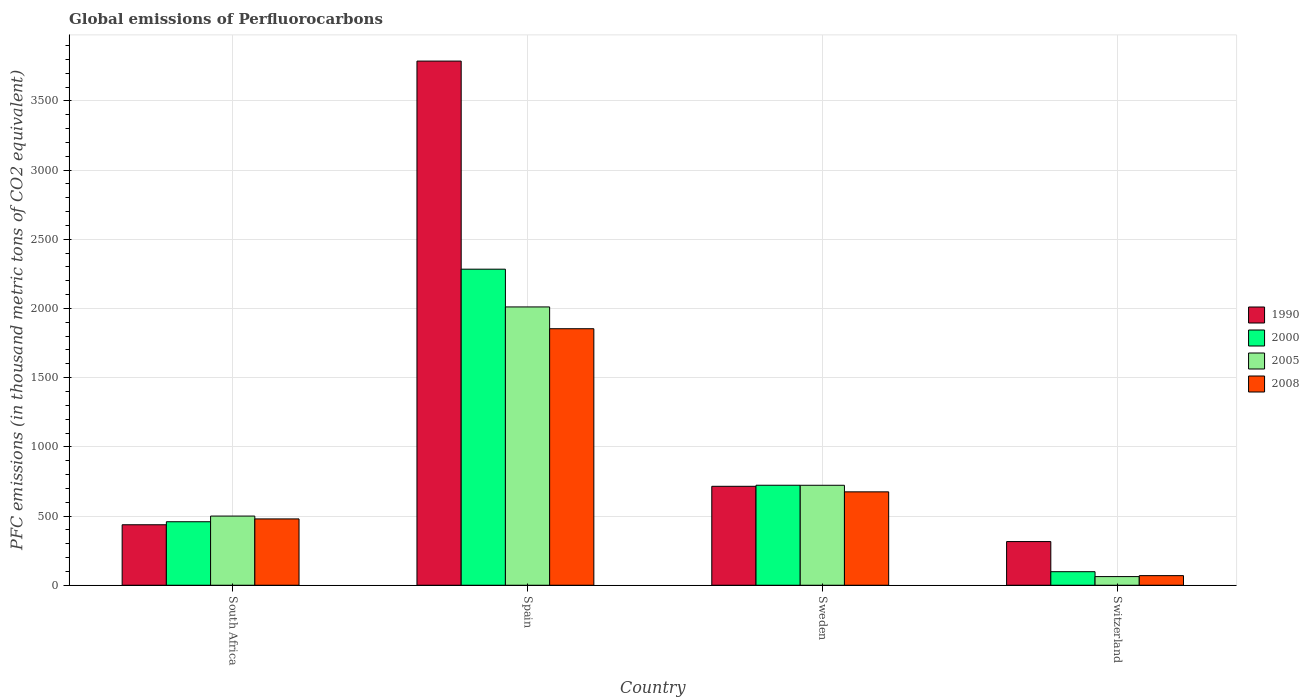How many different coloured bars are there?
Your answer should be compact. 4. How many bars are there on the 1st tick from the left?
Your answer should be very brief. 4. How many bars are there on the 4th tick from the right?
Your answer should be compact. 4. What is the label of the 2nd group of bars from the left?
Offer a very short reply. Spain. In how many cases, is the number of bars for a given country not equal to the number of legend labels?
Keep it short and to the point. 0. What is the global emissions of Perfluorocarbons in 1990 in Sweden?
Offer a terse response. 714.9. Across all countries, what is the maximum global emissions of Perfluorocarbons in 2008?
Offer a very short reply. 1853.5. Across all countries, what is the minimum global emissions of Perfluorocarbons in 1990?
Provide a succinct answer. 315.5. In which country was the global emissions of Perfluorocarbons in 1990 minimum?
Provide a short and direct response. Switzerland. What is the total global emissions of Perfluorocarbons in 2008 in the graph?
Ensure brevity in your answer.  3076.9. What is the difference between the global emissions of Perfluorocarbons in 2008 in Sweden and that in Switzerland?
Your response must be concise. 605.4. What is the difference between the global emissions of Perfluorocarbons in 2005 in Switzerland and the global emissions of Perfluorocarbons in 2008 in Spain?
Your answer should be compact. -1791. What is the average global emissions of Perfluorocarbons in 1990 per country?
Keep it short and to the point. 1313.7. What is the difference between the global emissions of Perfluorocarbons of/in 2005 and global emissions of Perfluorocarbons of/in 2000 in Spain?
Your answer should be very brief. -272.8. In how many countries, is the global emissions of Perfluorocarbons in 2000 greater than 1500 thousand metric tons?
Provide a short and direct response. 1. What is the ratio of the global emissions of Perfluorocarbons in 1990 in South Africa to that in Sweden?
Give a very brief answer. 0.61. Is the global emissions of Perfluorocarbons in 2005 in Sweden less than that in Switzerland?
Offer a terse response. No. Is the difference between the global emissions of Perfluorocarbons in 2005 in Spain and Switzerland greater than the difference between the global emissions of Perfluorocarbons in 2000 in Spain and Switzerland?
Ensure brevity in your answer.  No. What is the difference between the highest and the second highest global emissions of Perfluorocarbons in 2000?
Provide a short and direct response. -263.7. What is the difference between the highest and the lowest global emissions of Perfluorocarbons in 2000?
Give a very brief answer. 2185.9. In how many countries, is the global emissions of Perfluorocarbons in 2000 greater than the average global emissions of Perfluorocarbons in 2000 taken over all countries?
Make the answer very short. 1. Is the sum of the global emissions of Perfluorocarbons in 2008 in South Africa and Spain greater than the maximum global emissions of Perfluorocarbons in 1990 across all countries?
Make the answer very short. No. What does the 1st bar from the right in Spain represents?
Provide a short and direct response. 2008. How many bars are there?
Make the answer very short. 16. Are the values on the major ticks of Y-axis written in scientific E-notation?
Provide a succinct answer. No. Does the graph contain any zero values?
Make the answer very short. No. What is the title of the graph?
Offer a terse response. Global emissions of Perfluorocarbons. Does "1978" appear as one of the legend labels in the graph?
Your response must be concise. No. What is the label or title of the Y-axis?
Offer a very short reply. PFC emissions (in thousand metric tons of CO2 equivalent). What is the PFC emissions (in thousand metric tons of CO2 equivalent) of 1990 in South Africa?
Provide a short and direct response. 437. What is the PFC emissions (in thousand metric tons of CO2 equivalent) of 2000 in South Africa?
Your response must be concise. 458.8. What is the PFC emissions (in thousand metric tons of CO2 equivalent) of 2005 in South Africa?
Offer a very short reply. 499.8. What is the PFC emissions (in thousand metric tons of CO2 equivalent) in 2008 in South Africa?
Your answer should be compact. 479.2. What is the PFC emissions (in thousand metric tons of CO2 equivalent) of 1990 in Spain?
Your response must be concise. 3787.4. What is the PFC emissions (in thousand metric tons of CO2 equivalent) of 2000 in Spain?
Provide a short and direct response. 2283.8. What is the PFC emissions (in thousand metric tons of CO2 equivalent) of 2005 in Spain?
Offer a terse response. 2011. What is the PFC emissions (in thousand metric tons of CO2 equivalent) in 2008 in Spain?
Offer a very short reply. 1853.5. What is the PFC emissions (in thousand metric tons of CO2 equivalent) of 1990 in Sweden?
Provide a short and direct response. 714.9. What is the PFC emissions (in thousand metric tons of CO2 equivalent) of 2000 in Sweden?
Give a very brief answer. 722.5. What is the PFC emissions (in thousand metric tons of CO2 equivalent) in 2005 in Sweden?
Provide a succinct answer. 722.3. What is the PFC emissions (in thousand metric tons of CO2 equivalent) of 2008 in Sweden?
Ensure brevity in your answer.  674.8. What is the PFC emissions (in thousand metric tons of CO2 equivalent) in 1990 in Switzerland?
Your response must be concise. 315.5. What is the PFC emissions (in thousand metric tons of CO2 equivalent) in 2000 in Switzerland?
Your answer should be compact. 97.9. What is the PFC emissions (in thousand metric tons of CO2 equivalent) of 2005 in Switzerland?
Offer a terse response. 62.5. What is the PFC emissions (in thousand metric tons of CO2 equivalent) in 2008 in Switzerland?
Your answer should be compact. 69.4. Across all countries, what is the maximum PFC emissions (in thousand metric tons of CO2 equivalent) of 1990?
Provide a short and direct response. 3787.4. Across all countries, what is the maximum PFC emissions (in thousand metric tons of CO2 equivalent) of 2000?
Keep it short and to the point. 2283.8. Across all countries, what is the maximum PFC emissions (in thousand metric tons of CO2 equivalent) of 2005?
Give a very brief answer. 2011. Across all countries, what is the maximum PFC emissions (in thousand metric tons of CO2 equivalent) in 2008?
Provide a succinct answer. 1853.5. Across all countries, what is the minimum PFC emissions (in thousand metric tons of CO2 equivalent) of 1990?
Ensure brevity in your answer.  315.5. Across all countries, what is the minimum PFC emissions (in thousand metric tons of CO2 equivalent) of 2000?
Your response must be concise. 97.9. Across all countries, what is the minimum PFC emissions (in thousand metric tons of CO2 equivalent) in 2005?
Make the answer very short. 62.5. Across all countries, what is the minimum PFC emissions (in thousand metric tons of CO2 equivalent) of 2008?
Keep it short and to the point. 69.4. What is the total PFC emissions (in thousand metric tons of CO2 equivalent) in 1990 in the graph?
Provide a short and direct response. 5254.8. What is the total PFC emissions (in thousand metric tons of CO2 equivalent) of 2000 in the graph?
Your answer should be compact. 3563. What is the total PFC emissions (in thousand metric tons of CO2 equivalent) of 2005 in the graph?
Give a very brief answer. 3295.6. What is the total PFC emissions (in thousand metric tons of CO2 equivalent) of 2008 in the graph?
Your answer should be compact. 3076.9. What is the difference between the PFC emissions (in thousand metric tons of CO2 equivalent) of 1990 in South Africa and that in Spain?
Keep it short and to the point. -3350.4. What is the difference between the PFC emissions (in thousand metric tons of CO2 equivalent) in 2000 in South Africa and that in Spain?
Ensure brevity in your answer.  -1825. What is the difference between the PFC emissions (in thousand metric tons of CO2 equivalent) in 2005 in South Africa and that in Spain?
Keep it short and to the point. -1511.2. What is the difference between the PFC emissions (in thousand metric tons of CO2 equivalent) in 2008 in South Africa and that in Spain?
Offer a very short reply. -1374.3. What is the difference between the PFC emissions (in thousand metric tons of CO2 equivalent) in 1990 in South Africa and that in Sweden?
Ensure brevity in your answer.  -277.9. What is the difference between the PFC emissions (in thousand metric tons of CO2 equivalent) of 2000 in South Africa and that in Sweden?
Keep it short and to the point. -263.7. What is the difference between the PFC emissions (in thousand metric tons of CO2 equivalent) of 2005 in South Africa and that in Sweden?
Keep it short and to the point. -222.5. What is the difference between the PFC emissions (in thousand metric tons of CO2 equivalent) in 2008 in South Africa and that in Sweden?
Provide a succinct answer. -195.6. What is the difference between the PFC emissions (in thousand metric tons of CO2 equivalent) in 1990 in South Africa and that in Switzerland?
Offer a very short reply. 121.5. What is the difference between the PFC emissions (in thousand metric tons of CO2 equivalent) in 2000 in South Africa and that in Switzerland?
Ensure brevity in your answer.  360.9. What is the difference between the PFC emissions (in thousand metric tons of CO2 equivalent) of 2005 in South Africa and that in Switzerland?
Keep it short and to the point. 437.3. What is the difference between the PFC emissions (in thousand metric tons of CO2 equivalent) in 2008 in South Africa and that in Switzerland?
Offer a very short reply. 409.8. What is the difference between the PFC emissions (in thousand metric tons of CO2 equivalent) in 1990 in Spain and that in Sweden?
Make the answer very short. 3072.5. What is the difference between the PFC emissions (in thousand metric tons of CO2 equivalent) in 2000 in Spain and that in Sweden?
Offer a very short reply. 1561.3. What is the difference between the PFC emissions (in thousand metric tons of CO2 equivalent) of 2005 in Spain and that in Sweden?
Offer a terse response. 1288.7. What is the difference between the PFC emissions (in thousand metric tons of CO2 equivalent) of 2008 in Spain and that in Sweden?
Your answer should be compact. 1178.7. What is the difference between the PFC emissions (in thousand metric tons of CO2 equivalent) of 1990 in Spain and that in Switzerland?
Offer a very short reply. 3471.9. What is the difference between the PFC emissions (in thousand metric tons of CO2 equivalent) of 2000 in Spain and that in Switzerland?
Give a very brief answer. 2185.9. What is the difference between the PFC emissions (in thousand metric tons of CO2 equivalent) in 2005 in Spain and that in Switzerland?
Give a very brief answer. 1948.5. What is the difference between the PFC emissions (in thousand metric tons of CO2 equivalent) in 2008 in Spain and that in Switzerland?
Provide a short and direct response. 1784.1. What is the difference between the PFC emissions (in thousand metric tons of CO2 equivalent) in 1990 in Sweden and that in Switzerland?
Keep it short and to the point. 399.4. What is the difference between the PFC emissions (in thousand metric tons of CO2 equivalent) of 2000 in Sweden and that in Switzerland?
Make the answer very short. 624.6. What is the difference between the PFC emissions (in thousand metric tons of CO2 equivalent) in 2005 in Sweden and that in Switzerland?
Provide a succinct answer. 659.8. What is the difference between the PFC emissions (in thousand metric tons of CO2 equivalent) in 2008 in Sweden and that in Switzerland?
Provide a succinct answer. 605.4. What is the difference between the PFC emissions (in thousand metric tons of CO2 equivalent) in 1990 in South Africa and the PFC emissions (in thousand metric tons of CO2 equivalent) in 2000 in Spain?
Your answer should be very brief. -1846.8. What is the difference between the PFC emissions (in thousand metric tons of CO2 equivalent) in 1990 in South Africa and the PFC emissions (in thousand metric tons of CO2 equivalent) in 2005 in Spain?
Make the answer very short. -1574. What is the difference between the PFC emissions (in thousand metric tons of CO2 equivalent) in 1990 in South Africa and the PFC emissions (in thousand metric tons of CO2 equivalent) in 2008 in Spain?
Give a very brief answer. -1416.5. What is the difference between the PFC emissions (in thousand metric tons of CO2 equivalent) of 2000 in South Africa and the PFC emissions (in thousand metric tons of CO2 equivalent) of 2005 in Spain?
Provide a short and direct response. -1552.2. What is the difference between the PFC emissions (in thousand metric tons of CO2 equivalent) in 2000 in South Africa and the PFC emissions (in thousand metric tons of CO2 equivalent) in 2008 in Spain?
Your answer should be compact. -1394.7. What is the difference between the PFC emissions (in thousand metric tons of CO2 equivalent) of 2005 in South Africa and the PFC emissions (in thousand metric tons of CO2 equivalent) of 2008 in Spain?
Your answer should be very brief. -1353.7. What is the difference between the PFC emissions (in thousand metric tons of CO2 equivalent) of 1990 in South Africa and the PFC emissions (in thousand metric tons of CO2 equivalent) of 2000 in Sweden?
Offer a very short reply. -285.5. What is the difference between the PFC emissions (in thousand metric tons of CO2 equivalent) in 1990 in South Africa and the PFC emissions (in thousand metric tons of CO2 equivalent) in 2005 in Sweden?
Ensure brevity in your answer.  -285.3. What is the difference between the PFC emissions (in thousand metric tons of CO2 equivalent) in 1990 in South Africa and the PFC emissions (in thousand metric tons of CO2 equivalent) in 2008 in Sweden?
Keep it short and to the point. -237.8. What is the difference between the PFC emissions (in thousand metric tons of CO2 equivalent) in 2000 in South Africa and the PFC emissions (in thousand metric tons of CO2 equivalent) in 2005 in Sweden?
Offer a terse response. -263.5. What is the difference between the PFC emissions (in thousand metric tons of CO2 equivalent) in 2000 in South Africa and the PFC emissions (in thousand metric tons of CO2 equivalent) in 2008 in Sweden?
Make the answer very short. -216. What is the difference between the PFC emissions (in thousand metric tons of CO2 equivalent) of 2005 in South Africa and the PFC emissions (in thousand metric tons of CO2 equivalent) of 2008 in Sweden?
Your answer should be very brief. -175. What is the difference between the PFC emissions (in thousand metric tons of CO2 equivalent) in 1990 in South Africa and the PFC emissions (in thousand metric tons of CO2 equivalent) in 2000 in Switzerland?
Your answer should be very brief. 339.1. What is the difference between the PFC emissions (in thousand metric tons of CO2 equivalent) in 1990 in South Africa and the PFC emissions (in thousand metric tons of CO2 equivalent) in 2005 in Switzerland?
Your answer should be very brief. 374.5. What is the difference between the PFC emissions (in thousand metric tons of CO2 equivalent) of 1990 in South Africa and the PFC emissions (in thousand metric tons of CO2 equivalent) of 2008 in Switzerland?
Provide a short and direct response. 367.6. What is the difference between the PFC emissions (in thousand metric tons of CO2 equivalent) in 2000 in South Africa and the PFC emissions (in thousand metric tons of CO2 equivalent) in 2005 in Switzerland?
Make the answer very short. 396.3. What is the difference between the PFC emissions (in thousand metric tons of CO2 equivalent) in 2000 in South Africa and the PFC emissions (in thousand metric tons of CO2 equivalent) in 2008 in Switzerland?
Your answer should be very brief. 389.4. What is the difference between the PFC emissions (in thousand metric tons of CO2 equivalent) of 2005 in South Africa and the PFC emissions (in thousand metric tons of CO2 equivalent) of 2008 in Switzerland?
Your response must be concise. 430.4. What is the difference between the PFC emissions (in thousand metric tons of CO2 equivalent) in 1990 in Spain and the PFC emissions (in thousand metric tons of CO2 equivalent) in 2000 in Sweden?
Your answer should be compact. 3064.9. What is the difference between the PFC emissions (in thousand metric tons of CO2 equivalent) of 1990 in Spain and the PFC emissions (in thousand metric tons of CO2 equivalent) of 2005 in Sweden?
Offer a very short reply. 3065.1. What is the difference between the PFC emissions (in thousand metric tons of CO2 equivalent) of 1990 in Spain and the PFC emissions (in thousand metric tons of CO2 equivalent) of 2008 in Sweden?
Provide a short and direct response. 3112.6. What is the difference between the PFC emissions (in thousand metric tons of CO2 equivalent) in 2000 in Spain and the PFC emissions (in thousand metric tons of CO2 equivalent) in 2005 in Sweden?
Ensure brevity in your answer.  1561.5. What is the difference between the PFC emissions (in thousand metric tons of CO2 equivalent) in 2000 in Spain and the PFC emissions (in thousand metric tons of CO2 equivalent) in 2008 in Sweden?
Your answer should be compact. 1609. What is the difference between the PFC emissions (in thousand metric tons of CO2 equivalent) of 2005 in Spain and the PFC emissions (in thousand metric tons of CO2 equivalent) of 2008 in Sweden?
Provide a short and direct response. 1336.2. What is the difference between the PFC emissions (in thousand metric tons of CO2 equivalent) in 1990 in Spain and the PFC emissions (in thousand metric tons of CO2 equivalent) in 2000 in Switzerland?
Provide a succinct answer. 3689.5. What is the difference between the PFC emissions (in thousand metric tons of CO2 equivalent) of 1990 in Spain and the PFC emissions (in thousand metric tons of CO2 equivalent) of 2005 in Switzerland?
Offer a very short reply. 3724.9. What is the difference between the PFC emissions (in thousand metric tons of CO2 equivalent) of 1990 in Spain and the PFC emissions (in thousand metric tons of CO2 equivalent) of 2008 in Switzerland?
Your response must be concise. 3718. What is the difference between the PFC emissions (in thousand metric tons of CO2 equivalent) of 2000 in Spain and the PFC emissions (in thousand metric tons of CO2 equivalent) of 2005 in Switzerland?
Keep it short and to the point. 2221.3. What is the difference between the PFC emissions (in thousand metric tons of CO2 equivalent) in 2000 in Spain and the PFC emissions (in thousand metric tons of CO2 equivalent) in 2008 in Switzerland?
Your answer should be compact. 2214.4. What is the difference between the PFC emissions (in thousand metric tons of CO2 equivalent) in 2005 in Spain and the PFC emissions (in thousand metric tons of CO2 equivalent) in 2008 in Switzerland?
Your response must be concise. 1941.6. What is the difference between the PFC emissions (in thousand metric tons of CO2 equivalent) of 1990 in Sweden and the PFC emissions (in thousand metric tons of CO2 equivalent) of 2000 in Switzerland?
Give a very brief answer. 617. What is the difference between the PFC emissions (in thousand metric tons of CO2 equivalent) in 1990 in Sweden and the PFC emissions (in thousand metric tons of CO2 equivalent) in 2005 in Switzerland?
Give a very brief answer. 652.4. What is the difference between the PFC emissions (in thousand metric tons of CO2 equivalent) in 1990 in Sweden and the PFC emissions (in thousand metric tons of CO2 equivalent) in 2008 in Switzerland?
Offer a terse response. 645.5. What is the difference between the PFC emissions (in thousand metric tons of CO2 equivalent) of 2000 in Sweden and the PFC emissions (in thousand metric tons of CO2 equivalent) of 2005 in Switzerland?
Your response must be concise. 660. What is the difference between the PFC emissions (in thousand metric tons of CO2 equivalent) of 2000 in Sweden and the PFC emissions (in thousand metric tons of CO2 equivalent) of 2008 in Switzerland?
Make the answer very short. 653.1. What is the difference between the PFC emissions (in thousand metric tons of CO2 equivalent) of 2005 in Sweden and the PFC emissions (in thousand metric tons of CO2 equivalent) of 2008 in Switzerland?
Ensure brevity in your answer.  652.9. What is the average PFC emissions (in thousand metric tons of CO2 equivalent) in 1990 per country?
Offer a terse response. 1313.7. What is the average PFC emissions (in thousand metric tons of CO2 equivalent) in 2000 per country?
Provide a short and direct response. 890.75. What is the average PFC emissions (in thousand metric tons of CO2 equivalent) in 2005 per country?
Your answer should be very brief. 823.9. What is the average PFC emissions (in thousand metric tons of CO2 equivalent) in 2008 per country?
Ensure brevity in your answer.  769.23. What is the difference between the PFC emissions (in thousand metric tons of CO2 equivalent) in 1990 and PFC emissions (in thousand metric tons of CO2 equivalent) in 2000 in South Africa?
Ensure brevity in your answer.  -21.8. What is the difference between the PFC emissions (in thousand metric tons of CO2 equivalent) in 1990 and PFC emissions (in thousand metric tons of CO2 equivalent) in 2005 in South Africa?
Keep it short and to the point. -62.8. What is the difference between the PFC emissions (in thousand metric tons of CO2 equivalent) in 1990 and PFC emissions (in thousand metric tons of CO2 equivalent) in 2008 in South Africa?
Your answer should be compact. -42.2. What is the difference between the PFC emissions (in thousand metric tons of CO2 equivalent) in 2000 and PFC emissions (in thousand metric tons of CO2 equivalent) in 2005 in South Africa?
Your response must be concise. -41. What is the difference between the PFC emissions (in thousand metric tons of CO2 equivalent) of 2000 and PFC emissions (in thousand metric tons of CO2 equivalent) of 2008 in South Africa?
Provide a short and direct response. -20.4. What is the difference between the PFC emissions (in thousand metric tons of CO2 equivalent) of 2005 and PFC emissions (in thousand metric tons of CO2 equivalent) of 2008 in South Africa?
Give a very brief answer. 20.6. What is the difference between the PFC emissions (in thousand metric tons of CO2 equivalent) of 1990 and PFC emissions (in thousand metric tons of CO2 equivalent) of 2000 in Spain?
Your response must be concise. 1503.6. What is the difference between the PFC emissions (in thousand metric tons of CO2 equivalent) in 1990 and PFC emissions (in thousand metric tons of CO2 equivalent) in 2005 in Spain?
Keep it short and to the point. 1776.4. What is the difference between the PFC emissions (in thousand metric tons of CO2 equivalent) in 1990 and PFC emissions (in thousand metric tons of CO2 equivalent) in 2008 in Spain?
Make the answer very short. 1933.9. What is the difference between the PFC emissions (in thousand metric tons of CO2 equivalent) in 2000 and PFC emissions (in thousand metric tons of CO2 equivalent) in 2005 in Spain?
Your answer should be very brief. 272.8. What is the difference between the PFC emissions (in thousand metric tons of CO2 equivalent) in 2000 and PFC emissions (in thousand metric tons of CO2 equivalent) in 2008 in Spain?
Offer a very short reply. 430.3. What is the difference between the PFC emissions (in thousand metric tons of CO2 equivalent) of 2005 and PFC emissions (in thousand metric tons of CO2 equivalent) of 2008 in Spain?
Your answer should be compact. 157.5. What is the difference between the PFC emissions (in thousand metric tons of CO2 equivalent) of 1990 and PFC emissions (in thousand metric tons of CO2 equivalent) of 2005 in Sweden?
Keep it short and to the point. -7.4. What is the difference between the PFC emissions (in thousand metric tons of CO2 equivalent) of 1990 and PFC emissions (in thousand metric tons of CO2 equivalent) of 2008 in Sweden?
Provide a succinct answer. 40.1. What is the difference between the PFC emissions (in thousand metric tons of CO2 equivalent) of 2000 and PFC emissions (in thousand metric tons of CO2 equivalent) of 2005 in Sweden?
Offer a terse response. 0.2. What is the difference between the PFC emissions (in thousand metric tons of CO2 equivalent) in 2000 and PFC emissions (in thousand metric tons of CO2 equivalent) in 2008 in Sweden?
Provide a succinct answer. 47.7. What is the difference between the PFC emissions (in thousand metric tons of CO2 equivalent) of 2005 and PFC emissions (in thousand metric tons of CO2 equivalent) of 2008 in Sweden?
Keep it short and to the point. 47.5. What is the difference between the PFC emissions (in thousand metric tons of CO2 equivalent) in 1990 and PFC emissions (in thousand metric tons of CO2 equivalent) in 2000 in Switzerland?
Your answer should be compact. 217.6. What is the difference between the PFC emissions (in thousand metric tons of CO2 equivalent) of 1990 and PFC emissions (in thousand metric tons of CO2 equivalent) of 2005 in Switzerland?
Provide a short and direct response. 253. What is the difference between the PFC emissions (in thousand metric tons of CO2 equivalent) in 1990 and PFC emissions (in thousand metric tons of CO2 equivalent) in 2008 in Switzerland?
Keep it short and to the point. 246.1. What is the difference between the PFC emissions (in thousand metric tons of CO2 equivalent) of 2000 and PFC emissions (in thousand metric tons of CO2 equivalent) of 2005 in Switzerland?
Give a very brief answer. 35.4. What is the difference between the PFC emissions (in thousand metric tons of CO2 equivalent) of 2005 and PFC emissions (in thousand metric tons of CO2 equivalent) of 2008 in Switzerland?
Ensure brevity in your answer.  -6.9. What is the ratio of the PFC emissions (in thousand metric tons of CO2 equivalent) of 1990 in South Africa to that in Spain?
Give a very brief answer. 0.12. What is the ratio of the PFC emissions (in thousand metric tons of CO2 equivalent) of 2000 in South Africa to that in Spain?
Offer a very short reply. 0.2. What is the ratio of the PFC emissions (in thousand metric tons of CO2 equivalent) of 2005 in South Africa to that in Spain?
Your answer should be very brief. 0.25. What is the ratio of the PFC emissions (in thousand metric tons of CO2 equivalent) in 2008 in South Africa to that in Spain?
Your answer should be very brief. 0.26. What is the ratio of the PFC emissions (in thousand metric tons of CO2 equivalent) in 1990 in South Africa to that in Sweden?
Your response must be concise. 0.61. What is the ratio of the PFC emissions (in thousand metric tons of CO2 equivalent) in 2000 in South Africa to that in Sweden?
Offer a terse response. 0.64. What is the ratio of the PFC emissions (in thousand metric tons of CO2 equivalent) of 2005 in South Africa to that in Sweden?
Your answer should be very brief. 0.69. What is the ratio of the PFC emissions (in thousand metric tons of CO2 equivalent) in 2008 in South Africa to that in Sweden?
Offer a terse response. 0.71. What is the ratio of the PFC emissions (in thousand metric tons of CO2 equivalent) in 1990 in South Africa to that in Switzerland?
Provide a succinct answer. 1.39. What is the ratio of the PFC emissions (in thousand metric tons of CO2 equivalent) of 2000 in South Africa to that in Switzerland?
Provide a succinct answer. 4.69. What is the ratio of the PFC emissions (in thousand metric tons of CO2 equivalent) of 2005 in South Africa to that in Switzerland?
Offer a very short reply. 8. What is the ratio of the PFC emissions (in thousand metric tons of CO2 equivalent) in 2008 in South Africa to that in Switzerland?
Keep it short and to the point. 6.9. What is the ratio of the PFC emissions (in thousand metric tons of CO2 equivalent) of 1990 in Spain to that in Sweden?
Offer a very short reply. 5.3. What is the ratio of the PFC emissions (in thousand metric tons of CO2 equivalent) in 2000 in Spain to that in Sweden?
Give a very brief answer. 3.16. What is the ratio of the PFC emissions (in thousand metric tons of CO2 equivalent) in 2005 in Spain to that in Sweden?
Provide a succinct answer. 2.78. What is the ratio of the PFC emissions (in thousand metric tons of CO2 equivalent) in 2008 in Spain to that in Sweden?
Make the answer very short. 2.75. What is the ratio of the PFC emissions (in thousand metric tons of CO2 equivalent) in 1990 in Spain to that in Switzerland?
Ensure brevity in your answer.  12. What is the ratio of the PFC emissions (in thousand metric tons of CO2 equivalent) of 2000 in Spain to that in Switzerland?
Ensure brevity in your answer.  23.33. What is the ratio of the PFC emissions (in thousand metric tons of CO2 equivalent) in 2005 in Spain to that in Switzerland?
Give a very brief answer. 32.18. What is the ratio of the PFC emissions (in thousand metric tons of CO2 equivalent) in 2008 in Spain to that in Switzerland?
Make the answer very short. 26.71. What is the ratio of the PFC emissions (in thousand metric tons of CO2 equivalent) in 1990 in Sweden to that in Switzerland?
Offer a very short reply. 2.27. What is the ratio of the PFC emissions (in thousand metric tons of CO2 equivalent) in 2000 in Sweden to that in Switzerland?
Your answer should be compact. 7.38. What is the ratio of the PFC emissions (in thousand metric tons of CO2 equivalent) of 2005 in Sweden to that in Switzerland?
Provide a succinct answer. 11.56. What is the ratio of the PFC emissions (in thousand metric tons of CO2 equivalent) in 2008 in Sweden to that in Switzerland?
Offer a terse response. 9.72. What is the difference between the highest and the second highest PFC emissions (in thousand metric tons of CO2 equivalent) of 1990?
Offer a very short reply. 3072.5. What is the difference between the highest and the second highest PFC emissions (in thousand metric tons of CO2 equivalent) of 2000?
Offer a very short reply. 1561.3. What is the difference between the highest and the second highest PFC emissions (in thousand metric tons of CO2 equivalent) of 2005?
Ensure brevity in your answer.  1288.7. What is the difference between the highest and the second highest PFC emissions (in thousand metric tons of CO2 equivalent) in 2008?
Ensure brevity in your answer.  1178.7. What is the difference between the highest and the lowest PFC emissions (in thousand metric tons of CO2 equivalent) in 1990?
Give a very brief answer. 3471.9. What is the difference between the highest and the lowest PFC emissions (in thousand metric tons of CO2 equivalent) in 2000?
Provide a short and direct response. 2185.9. What is the difference between the highest and the lowest PFC emissions (in thousand metric tons of CO2 equivalent) in 2005?
Keep it short and to the point. 1948.5. What is the difference between the highest and the lowest PFC emissions (in thousand metric tons of CO2 equivalent) of 2008?
Offer a very short reply. 1784.1. 